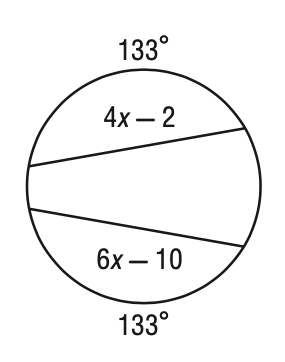Answer the mathemtical geometry problem and directly provide the correct option letter.
Question: Solve for x in the figure.
Choices: A: 2 B: 3 C: 4 D: 6 C 